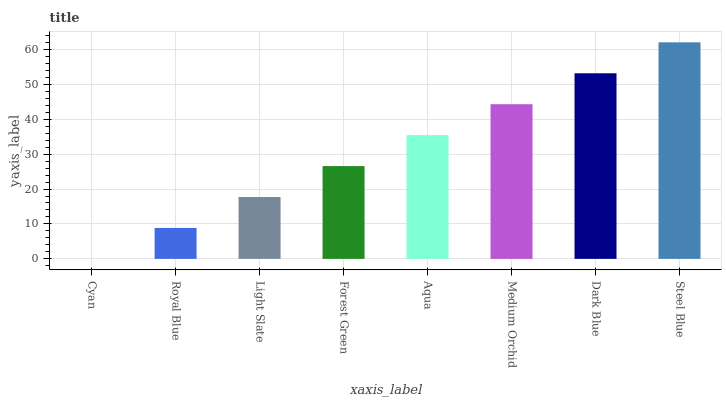Is Cyan the minimum?
Answer yes or no. Yes. Is Steel Blue the maximum?
Answer yes or no. Yes. Is Royal Blue the minimum?
Answer yes or no. No. Is Royal Blue the maximum?
Answer yes or no. No. Is Royal Blue greater than Cyan?
Answer yes or no. Yes. Is Cyan less than Royal Blue?
Answer yes or no. Yes. Is Cyan greater than Royal Blue?
Answer yes or no. No. Is Royal Blue less than Cyan?
Answer yes or no. No. Is Aqua the high median?
Answer yes or no. Yes. Is Forest Green the low median?
Answer yes or no. Yes. Is Medium Orchid the high median?
Answer yes or no. No. Is Royal Blue the low median?
Answer yes or no. No. 